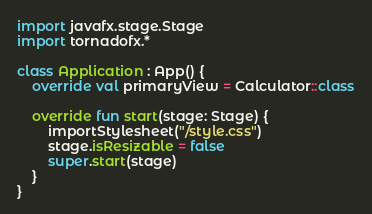<code> <loc_0><loc_0><loc_500><loc_500><_Kotlin_>import javafx.stage.Stage
import tornadofx.*

class Application : App() {
    override val primaryView = Calculator::class

    override fun start(stage: Stage) {
        importStylesheet("/style.css")
        stage.isResizable = false
        super.start(stage)
    }
}</code> 